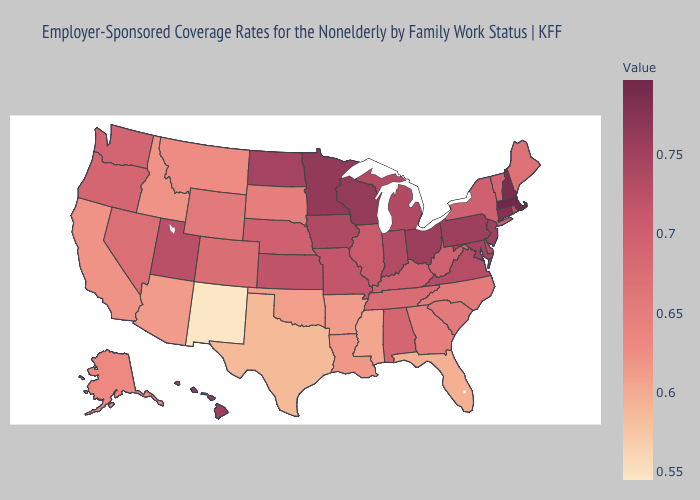Does the map have missing data?
Write a very short answer. No. Does Indiana have a higher value than Kentucky?
Concise answer only. Yes. Which states have the highest value in the USA?
Short answer required. Massachusetts. Among the states that border Florida , which have the lowest value?
Short answer required. Georgia. Does New Jersey have a lower value than North Carolina?
Give a very brief answer. No. Does Arizona have the highest value in the USA?
Answer briefly. No. 